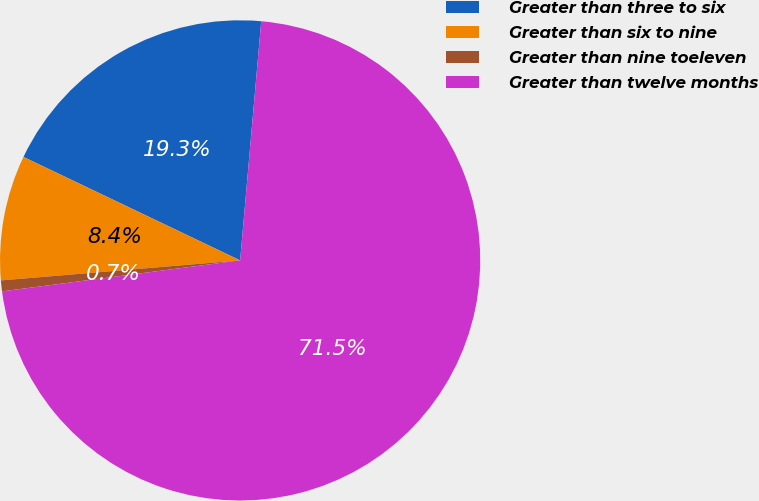Convert chart to OTSL. <chart><loc_0><loc_0><loc_500><loc_500><pie_chart><fcel>Greater than three to six<fcel>Greater than six to nine<fcel>Greater than nine toeleven<fcel>Greater than twelve months<nl><fcel>19.31%<fcel>8.42%<fcel>0.73%<fcel>71.54%<nl></chart> 